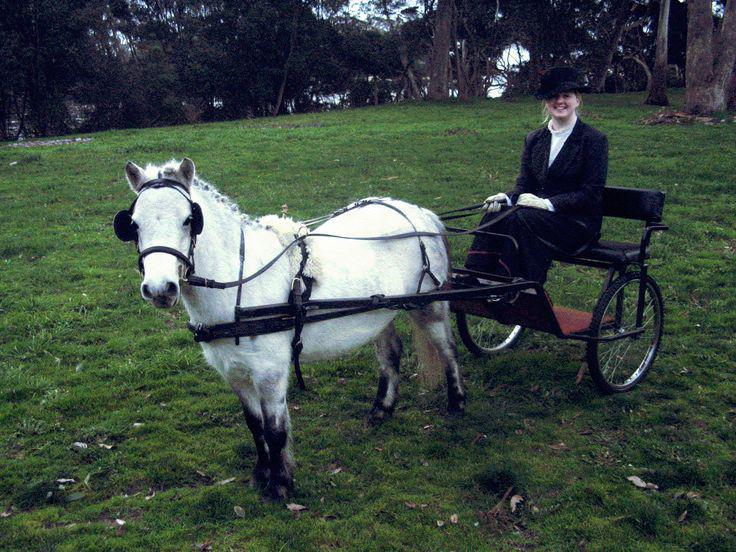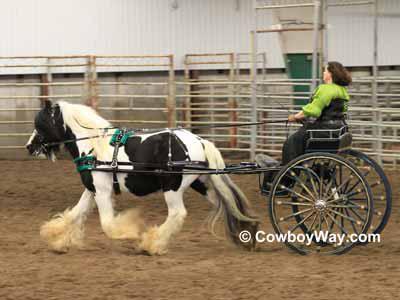The first image is the image on the left, the second image is the image on the right. Analyze the images presented: Is the assertion "there is exactly one person in the image on the right." valid? Answer yes or no. Yes. 